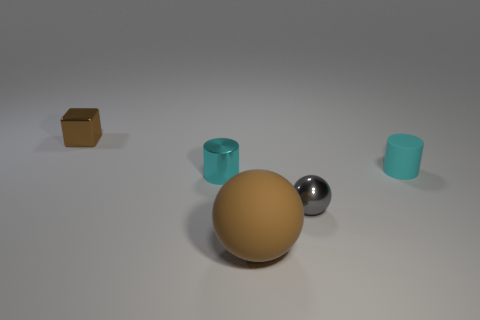Are there fewer tiny cyan rubber cylinders in front of the large ball than green objects?
Give a very brief answer. No. Is the tiny brown block made of the same material as the brown sphere?
Provide a succinct answer. No. What number of things are either tiny balls or blue balls?
Give a very brief answer. 1. What number of small cyan things are the same material as the small ball?
Offer a terse response. 1. What is the size of the gray metallic thing that is the same shape as the large brown matte object?
Provide a short and direct response. Small. There is a small metallic cylinder; are there any large brown matte spheres to the left of it?
Your answer should be compact. No. What material is the big object?
Give a very brief answer. Rubber. There is a small metal thing that is right of the brown sphere; is it the same color as the large object?
Your response must be concise. No. Is there anything else that has the same shape as the small cyan shiny object?
Keep it short and to the point. Yes. What color is the other thing that is the same shape as the gray object?
Provide a succinct answer. Brown. 